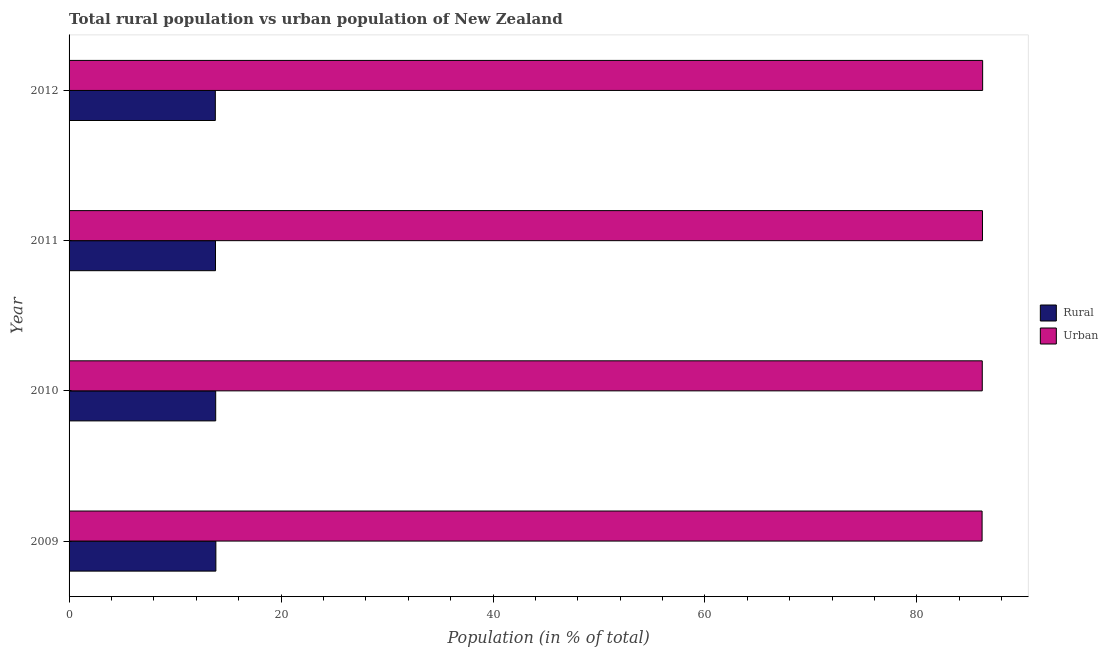How many different coloured bars are there?
Your response must be concise. 2. How many bars are there on the 3rd tick from the top?
Keep it short and to the point. 2. How many bars are there on the 4th tick from the bottom?
Your response must be concise. 2. What is the label of the 3rd group of bars from the top?
Your answer should be very brief. 2010. In how many cases, is the number of bars for a given year not equal to the number of legend labels?
Give a very brief answer. 0. What is the rural population in 2010?
Your answer should be very brief. 13.84. Across all years, what is the maximum urban population?
Your answer should be very brief. 86.2. Across all years, what is the minimum urban population?
Your answer should be compact. 86.15. What is the total rural population in the graph?
Give a very brief answer. 55.3. What is the difference between the rural population in 2009 and that in 2012?
Give a very brief answer. 0.05. What is the difference between the urban population in 2009 and the rural population in 2012?
Offer a very short reply. 72.35. What is the average urban population per year?
Provide a succinct answer. 86.17. In the year 2011, what is the difference between the urban population and rural population?
Your answer should be compact. 72.37. In how many years, is the rural population greater than 68 %?
Give a very brief answer. 0. What is the ratio of the rural population in 2010 to that in 2012?
Your answer should be compact. 1. Is the urban population in 2010 less than that in 2012?
Ensure brevity in your answer.  Yes. Is the difference between the urban population in 2009 and 2012 greater than the difference between the rural population in 2009 and 2012?
Make the answer very short. No. What is the difference between the highest and the second highest urban population?
Keep it short and to the point. 0.02. In how many years, is the rural population greater than the average rural population taken over all years?
Keep it short and to the point. 2. Is the sum of the urban population in 2009 and 2012 greater than the maximum rural population across all years?
Provide a short and direct response. Yes. What does the 2nd bar from the top in 2010 represents?
Your answer should be very brief. Rural. What does the 2nd bar from the bottom in 2012 represents?
Give a very brief answer. Urban. How many bars are there?
Ensure brevity in your answer.  8. Are all the bars in the graph horizontal?
Make the answer very short. Yes. What is the difference between two consecutive major ticks on the X-axis?
Give a very brief answer. 20. Are the values on the major ticks of X-axis written in scientific E-notation?
Make the answer very short. No. What is the title of the graph?
Offer a terse response. Total rural population vs urban population of New Zealand. Does "Rural" appear as one of the legend labels in the graph?
Offer a very short reply. Yes. What is the label or title of the X-axis?
Your response must be concise. Population (in % of total). What is the label or title of the Y-axis?
Give a very brief answer. Year. What is the Population (in % of total) of Rural in 2009?
Your answer should be compact. 13.85. What is the Population (in % of total) of Urban in 2009?
Ensure brevity in your answer.  86.15. What is the Population (in % of total) of Rural in 2010?
Your answer should be compact. 13.84. What is the Population (in % of total) in Urban in 2010?
Offer a terse response. 86.17. What is the Population (in % of total) of Rural in 2011?
Keep it short and to the point. 13.82. What is the Population (in % of total) in Urban in 2011?
Ensure brevity in your answer.  86.18. What is the Population (in % of total) in Rural in 2012?
Offer a terse response. 13.8. What is the Population (in % of total) of Urban in 2012?
Give a very brief answer. 86.2. Across all years, what is the maximum Population (in % of total) of Rural?
Provide a short and direct response. 13.85. Across all years, what is the maximum Population (in % of total) of Urban?
Your answer should be compact. 86.2. Across all years, what is the minimum Population (in % of total) in Rural?
Your answer should be very brief. 13.8. Across all years, what is the minimum Population (in % of total) of Urban?
Provide a succinct answer. 86.15. What is the total Population (in % of total) in Rural in the graph?
Make the answer very short. 55.3. What is the total Population (in % of total) in Urban in the graph?
Make the answer very short. 344.7. What is the difference between the Population (in % of total) in Rural in 2009 and that in 2010?
Offer a very short reply. 0.02. What is the difference between the Population (in % of total) of Urban in 2009 and that in 2010?
Your response must be concise. -0.02. What is the difference between the Population (in % of total) of Rural in 2009 and that in 2011?
Offer a terse response. 0.04. What is the difference between the Population (in % of total) in Urban in 2009 and that in 2011?
Give a very brief answer. -0.04. What is the difference between the Population (in % of total) of Rural in 2009 and that in 2012?
Make the answer very short. 0.05. What is the difference between the Population (in % of total) in Urban in 2009 and that in 2012?
Keep it short and to the point. -0.05. What is the difference between the Population (in % of total) of Rural in 2010 and that in 2011?
Your response must be concise. 0.02. What is the difference between the Population (in % of total) of Urban in 2010 and that in 2011?
Your answer should be compact. -0.02. What is the difference between the Population (in % of total) in Rural in 2010 and that in 2012?
Your answer should be very brief. 0.04. What is the difference between the Population (in % of total) of Urban in 2010 and that in 2012?
Keep it short and to the point. -0.04. What is the difference between the Population (in % of total) of Rural in 2011 and that in 2012?
Your response must be concise. 0.02. What is the difference between the Population (in % of total) in Urban in 2011 and that in 2012?
Keep it short and to the point. -0.02. What is the difference between the Population (in % of total) in Rural in 2009 and the Population (in % of total) in Urban in 2010?
Make the answer very short. -72.31. What is the difference between the Population (in % of total) of Rural in 2009 and the Population (in % of total) of Urban in 2011?
Offer a terse response. -72.33. What is the difference between the Population (in % of total) of Rural in 2009 and the Population (in % of total) of Urban in 2012?
Keep it short and to the point. -72.35. What is the difference between the Population (in % of total) of Rural in 2010 and the Population (in % of total) of Urban in 2011?
Give a very brief answer. -72.35. What is the difference between the Population (in % of total) of Rural in 2010 and the Population (in % of total) of Urban in 2012?
Your response must be concise. -72.36. What is the difference between the Population (in % of total) in Rural in 2011 and the Population (in % of total) in Urban in 2012?
Keep it short and to the point. -72.38. What is the average Population (in % of total) of Rural per year?
Ensure brevity in your answer.  13.83. What is the average Population (in % of total) in Urban per year?
Ensure brevity in your answer.  86.17. In the year 2009, what is the difference between the Population (in % of total) in Rural and Population (in % of total) in Urban?
Keep it short and to the point. -72.3. In the year 2010, what is the difference between the Population (in % of total) in Rural and Population (in % of total) in Urban?
Offer a terse response. -72.33. In the year 2011, what is the difference between the Population (in % of total) of Rural and Population (in % of total) of Urban?
Keep it short and to the point. -72.37. In the year 2012, what is the difference between the Population (in % of total) of Rural and Population (in % of total) of Urban?
Offer a terse response. -72.4. What is the ratio of the Population (in % of total) in Rural in 2009 to that in 2010?
Make the answer very short. 1. What is the ratio of the Population (in % of total) in Rural in 2009 to that in 2011?
Keep it short and to the point. 1. What is the ratio of the Population (in % of total) in Urban in 2009 to that in 2012?
Ensure brevity in your answer.  1. What is the ratio of the Population (in % of total) of Rural in 2010 to that in 2012?
Your response must be concise. 1. What is the ratio of the Population (in % of total) of Urban in 2010 to that in 2012?
Your response must be concise. 1. What is the ratio of the Population (in % of total) in Rural in 2011 to that in 2012?
Keep it short and to the point. 1. What is the ratio of the Population (in % of total) of Urban in 2011 to that in 2012?
Give a very brief answer. 1. What is the difference between the highest and the second highest Population (in % of total) of Rural?
Provide a succinct answer. 0.02. What is the difference between the highest and the second highest Population (in % of total) in Urban?
Provide a short and direct response. 0.02. What is the difference between the highest and the lowest Population (in % of total) of Rural?
Your response must be concise. 0.05. What is the difference between the highest and the lowest Population (in % of total) in Urban?
Your response must be concise. 0.05. 